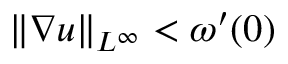Convert formula to latex. <formula><loc_0><loc_0><loc_500><loc_500>\| \nabla u \| _ { L ^ { \infty } } < \omega ^ { \prime } ( 0 )</formula> 